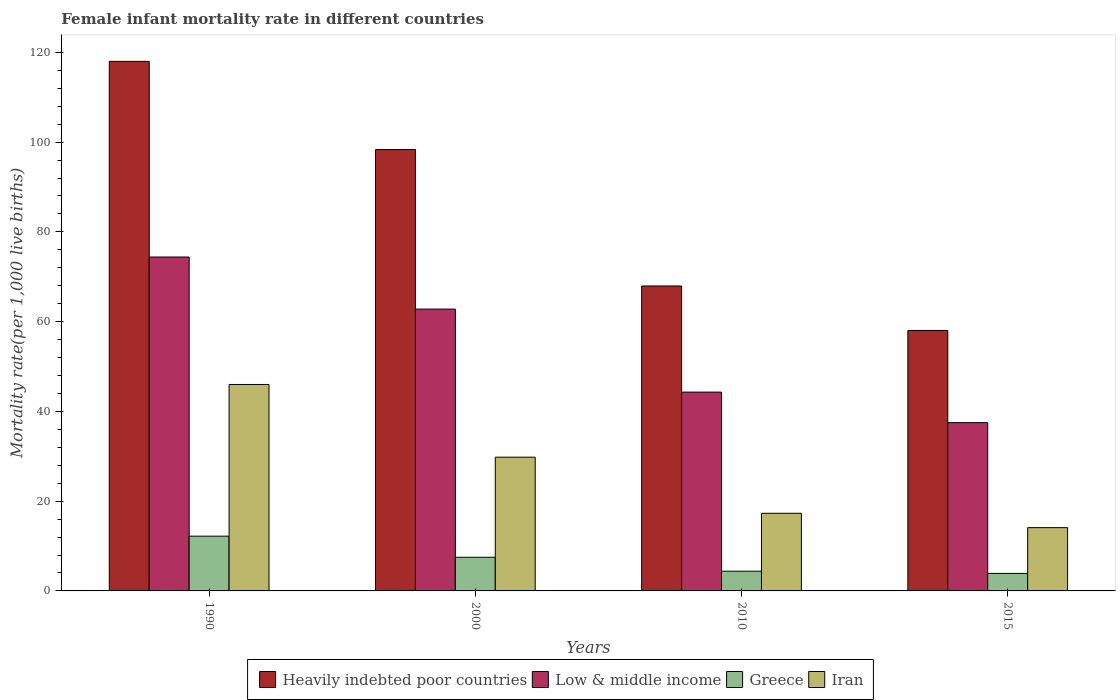How many different coloured bars are there?
Your answer should be compact. 4. How many groups of bars are there?
Offer a terse response. 4. Are the number of bars per tick equal to the number of legend labels?
Your response must be concise. Yes. How many bars are there on the 1st tick from the left?
Keep it short and to the point. 4. How many bars are there on the 3rd tick from the right?
Make the answer very short. 4. What is the label of the 4th group of bars from the left?
Your response must be concise. 2015. In how many cases, is the number of bars for a given year not equal to the number of legend labels?
Your answer should be very brief. 0. What is the female infant mortality rate in Greece in 2010?
Offer a very short reply. 4.4. Across all years, what is the maximum female infant mortality rate in Heavily indebted poor countries?
Your answer should be compact. 118. Across all years, what is the minimum female infant mortality rate in Low & middle income?
Give a very brief answer. 37.5. In which year was the female infant mortality rate in Greece minimum?
Provide a short and direct response. 2015. What is the total female infant mortality rate in Low & middle income in the graph?
Offer a terse response. 219. What is the difference between the female infant mortality rate in Low & middle income in 1990 and that in 2015?
Ensure brevity in your answer.  36.9. What is the difference between the female infant mortality rate in Heavily indebted poor countries in 2000 and the female infant mortality rate in Greece in 1990?
Provide a short and direct response. 86.15. What is the average female infant mortality rate in Low & middle income per year?
Offer a terse response. 54.75. In the year 2000, what is the difference between the female infant mortality rate in Iran and female infant mortality rate in Greece?
Your answer should be very brief. 22.3. In how many years, is the female infant mortality rate in Iran greater than 112?
Make the answer very short. 0. What is the ratio of the female infant mortality rate in Heavily indebted poor countries in 1990 to that in 2010?
Offer a very short reply. 1.74. Is the difference between the female infant mortality rate in Iran in 1990 and 2010 greater than the difference between the female infant mortality rate in Greece in 1990 and 2010?
Your answer should be very brief. Yes. What is the difference between the highest and the second highest female infant mortality rate in Low & middle income?
Give a very brief answer. 11.6. What is the difference between the highest and the lowest female infant mortality rate in Greece?
Ensure brevity in your answer.  8.3. In how many years, is the female infant mortality rate in Greece greater than the average female infant mortality rate in Greece taken over all years?
Your answer should be very brief. 2. What does the 1st bar from the left in 2015 represents?
Offer a very short reply. Heavily indebted poor countries. How many bars are there?
Give a very brief answer. 16. Are the values on the major ticks of Y-axis written in scientific E-notation?
Provide a succinct answer. No. Does the graph contain grids?
Your answer should be compact. No. Where does the legend appear in the graph?
Provide a succinct answer. Bottom center. How are the legend labels stacked?
Your response must be concise. Horizontal. What is the title of the graph?
Ensure brevity in your answer.  Female infant mortality rate in different countries. Does "Djibouti" appear as one of the legend labels in the graph?
Your response must be concise. No. What is the label or title of the Y-axis?
Offer a terse response. Mortality rate(per 1,0 live births). What is the Mortality rate(per 1,000 live births) of Heavily indebted poor countries in 1990?
Your response must be concise. 118. What is the Mortality rate(per 1,000 live births) of Low & middle income in 1990?
Your answer should be compact. 74.4. What is the Mortality rate(per 1,000 live births) of Greece in 1990?
Give a very brief answer. 12.2. What is the Mortality rate(per 1,000 live births) in Heavily indebted poor countries in 2000?
Provide a short and direct response. 98.35. What is the Mortality rate(per 1,000 live births) of Low & middle income in 2000?
Offer a terse response. 62.8. What is the Mortality rate(per 1,000 live births) of Iran in 2000?
Your answer should be very brief. 29.8. What is the Mortality rate(per 1,000 live births) in Heavily indebted poor countries in 2010?
Your answer should be very brief. 67.95. What is the Mortality rate(per 1,000 live births) of Low & middle income in 2010?
Offer a very short reply. 44.3. What is the Mortality rate(per 1,000 live births) of Heavily indebted poor countries in 2015?
Make the answer very short. 58.04. What is the Mortality rate(per 1,000 live births) in Low & middle income in 2015?
Your answer should be compact. 37.5. What is the Mortality rate(per 1,000 live births) of Greece in 2015?
Make the answer very short. 3.9. Across all years, what is the maximum Mortality rate(per 1,000 live births) in Heavily indebted poor countries?
Keep it short and to the point. 118. Across all years, what is the maximum Mortality rate(per 1,000 live births) of Low & middle income?
Your answer should be compact. 74.4. Across all years, what is the maximum Mortality rate(per 1,000 live births) of Iran?
Make the answer very short. 46. Across all years, what is the minimum Mortality rate(per 1,000 live births) in Heavily indebted poor countries?
Make the answer very short. 58.04. Across all years, what is the minimum Mortality rate(per 1,000 live births) in Low & middle income?
Ensure brevity in your answer.  37.5. Across all years, what is the minimum Mortality rate(per 1,000 live births) in Greece?
Keep it short and to the point. 3.9. What is the total Mortality rate(per 1,000 live births) of Heavily indebted poor countries in the graph?
Offer a very short reply. 342.34. What is the total Mortality rate(per 1,000 live births) in Low & middle income in the graph?
Your answer should be very brief. 219. What is the total Mortality rate(per 1,000 live births) in Greece in the graph?
Your response must be concise. 28. What is the total Mortality rate(per 1,000 live births) of Iran in the graph?
Make the answer very short. 107.2. What is the difference between the Mortality rate(per 1,000 live births) in Heavily indebted poor countries in 1990 and that in 2000?
Provide a succinct answer. 19.65. What is the difference between the Mortality rate(per 1,000 live births) of Greece in 1990 and that in 2000?
Your answer should be very brief. 4.7. What is the difference between the Mortality rate(per 1,000 live births) of Iran in 1990 and that in 2000?
Offer a very short reply. 16.2. What is the difference between the Mortality rate(per 1,000 live births) of Heavily indebted poor countries in 1990 and that in 2010?
Give a very brief answer. 50.05. What is the difference between the Mortality rate(per 1,000 live births) in Low & middle income in 1990 and that in 2010?
Your answer should be compact. 30.1. What is the difference between the Mortality rate(per 1,000 live births) of Greece in 1990 and that in 2010?
Your response must be concise. 7.8. What is the difference between the Mortality rate(per 1,000 live births) of Iran in 1990 and that in 2010?
Make the answer very short. 28.7. What is the difference between the Mortality rate(per 1,000 live births) of Heavily indebted poor countries in 1990 and that in 2015?
Your answer should be very brief. 59.96. What is the difference between the Mortality rate(per 1,000 live births) in Low & middle income in 1990 and that in 2015?
Your answer should be compact. 36.9. What is the difference between the Mortality rate(per 1,000 live births) in Greece in 1990 and that in 2015?
Make the answer very short. 8.3. What is the difference between the Mortality rate(per 1,000 live births) in Iran in 1990 and that in 2015?
Provide a succinct answer. 31.9. What is the difference between the Mortality rate(per 1,000 live births) in Heavily indebted poor countries in 2000 and that in 2010?
Your answer should be very brief. 30.4. What is the difference between the Mortality rate(per 1,000 live births) in Heavily indebted poor countries in 2000 and that in 2015?
Keep it short and to the point. 40.31. What is the difference between the Mortality rate(per 1,000 live births) in Low & middle income in 2000 and that in 2015?
Offer a very short reply. 25.3. What is the difference between the Mortality rate(per 1,000 live births) of Greece in 2000 and that in 2015?
Offer a very short reply. 3.6. What is the difference between the Mortality rate(per 1,000 live births) in Iran in 2000 and that in 2015?
Provide a short and direct response. 15.7. What is the difference between the Mortality rate(per 1,000 live births) of Heavily indebted poor countries in 2010 and that in 2015?
Ensure brevity in your answer.  9.91. What is the difference between the Mortality rate(per 1,000 live births) in Low & middle income in 2010 and that in 2015?
Ensure brevity in your answer.  6.8. What is the difference between the Mortality rate(per 1,000 live births) in Greece in 2010 and that in 2015?
Keep it short and to the point. 0.5. What is the difference between the Mortality rate(per 1,000 live births) in Heavily indebted poor countries in 1990 and the Mortality rate(per 1,000 live births) in Low & middle income in 2000?
Ensure brevity in your answer.  55.2. What is the difference between the Mortality rate(per 1,000 live births) of Heavily indebted poor countries in 1990 and the Mortality rate(per 1,000 live births) of Greece in 2000?
Provide a succinct answer. 110.5. What is the difference between the Mortality rate(per 1,000 live births) in Heavily indebted poor countries in 1990 and the Mortality rate(per 1,000 live births) in Iran in 2000?
Your answer should be very brief. 88.2. What is the difference between the Mortality rate(per 1,000 live births) in Low & middle income in 1990 and the Mortality rate(per 1,000 live births) in Greece in 2000?
Ensure brevity in your answer.  66.9. What is the difference between the Mortality rate(per 1,000 live births) of Low & middle income in 1990 and the Mortality rate(per 1,000 live births) of Iran in 2000?
Keep it short and to the point. 44.6. What is the difference between the Mortality rate(per 1,000 live births) in Greece in 1990 and the Mortality rate(per 1,000 live births) in Iran in 2000?
Give a very brief answer. -17.6. What is the difference between the Mortality rate(per 1,000 live births) of Heavily indebted poor countries in 1990 and the Mortality rate(per 1,000 live births) of Low & middle income in 2010?
Make the answer very short. 73.7. What is the difference between the Mortality rate(per 1,000 live births) in Heavily indebted poor countries in 1990 and the Mortality rate(per 1,000 live births) in Greece in 2010?
Make the answer very short. 113.6. What is the difference between the Mortality rate(per 1,000 live births) in Heavily indebted poor countries in 1990 and the Mortality rate(per 1,000 live births) in Iran in 2010?
Your answer should be compact. 100.7. What is the difference between the Mortality rate(per 1,000 live births) in Low & middle income in 1990 and the Mortality rate(per 1,000 live births) in Iran in 2010?
Provide a short and direct response. 57.1. What is the difference between the Mortality rate(per 1,000 live births) of Heavily indebted poor countries in 1990 and the Mortality rate(per 1,000 live births) of Low & middle income in 2015?
Ensure brevity in your answer.  80.5. What is the difference between the Mortality rate(per 1,000 live births) in Heavily indebted poor countries in 1990 and the Mortality rate(per 1,000 live births) in Greece in 2015?
Ensure brevity in your answer.  114.1. What is the difference between the Mortality rate(per 1,000 live births) of Heavily indebted poor countries in 1990 and the Mortality rate(per 1,000 live births) of Iran in 2015?
Your answer should be very brief. 103.9. What is the difference between the Mortality rate(per 1,000 live births) of Low & middle income in 1990 and the Mortality rate(per 1,000 live births) of Greece in 2015?
Your answer should be very brief. 70.5. What is the difference between the Mortality rate(per 1,000 live births) in Low & middle income in 1990 and the Mortality rate(per 1,000 live births) in Iran in 2015?
Your answer should be very brief. 60.3. What is the difference between the Mortality rate(per 1,000 live births) in Heavily indebted poor countries in 2000 and the Mortality rate(per 1,000 live births) in Low & middle income in 2010?
Your answer should be very brief. 54.05. What is the difference between the Mortality rate(per 1,000 live births) in Heavily indebted poor countries in 2000 and the Mortality rate(per 1,000 live births) in Greece in 2010?
Provide a short and direct response. 93.95. What is the difference between the Mortality rate(per 1,000 live births) in Heavily indebted poor countries in 2000 and the Mortality rate(per 1,000 live births) in Iran in 2010?
Offer a very short reply. 81.05. What is the difference between the Mortality rate(per 1,000 live births) in Low & middle income in 2000 and the Mortality rate(per 1,000 live births) in Greece in 2010?
Keep it short and to the point. 58.4. What is the difference between the Mortality rate(per 1,000 live births) of Low & middle income in 2000 and the Mortality rate(per 1,000 live births) of Iran in 2010?
Ensure brevity in your answer.  45.5. What is the difference between the Mortality rate(per 1,000 live births) of Heavily indebted poor countries in 2000 and the Mortality rate(per 1,000 live births) of Low & middle income in 2015?
Ensure brevity in your answer.  60.85. What is the difference between the Mortality rate(per 1,000 live births) in Heavily indebted poor countries in 2000 and the Mortality rate(per 1,000 live births) in Greece in 2015?
Your response must be concise. 94.45. What is the difference between the Mortality rate(per 1,000 live births) in Heavily indebted poor countries in 2000 and the Mortality rate(per 1,000 live births) in Iran in 2015?
Your answer should be very brief. 84.25. What is the difference between the Mortality rate(per 1,000 live births) in Low & middle income in 2000 and the Mortality rate(per 1,000 live births) in Greece in 2015?
Offer a terse response. 58.9. What is the difference between the Mortality rate(per 1,000 live births) of Low & middle income in 2000 and the Mortality rate(per 1,000 live births) of Iran in 2015?
Ensure brevity in your answer.  48.7. What is the difference between the Mortality rate(per 1,000 live births) in Greece in 2000 and the Mortality rate(per 1,000 live births) in Iran in 2015?
Your answer should be very brief. -6.6. What is the difference between the Mortality rate(per 1,000 live births) in Heavily indebted poor countries in 2010 and the Mortality rate(per 1,000 live births) in Low & middle income in 2015?
Offer a terse response. 30.45. What is the difference between the Mortality rate(per 1,000 live births) of Heavily indebted poor countries in 2010 and the Mortality rate(per 1,000 live births) of Greece in 2015?
Provide a short and direct response. 64.05. What is the difference between the Mortality rate(per 1,000 live births) in Heavily indebted poor countries in 2010 and the Mortality rate(per 1,000 live births) in Iran in 2015?
Provide a succinct answer. 53.85. What is the difference between the Mortality rate(per 1,000 live births) of Low & middle income in 2010 and the Mortality rate(per 1,000 live births) of Greece in 2015?
Keep it short and to the point. 40.4. What is the difference between the Mortality rate(per 1,000 live births) of Low & middle income in 2010 and the Mortality rate(per 1,000 live births) of Iran in 2015?
Make the answer very short. 30.2. What is the difference between the Mortality rate(per 1,000 live births) of Greece in 2010 and the Mortality rate(per 1,000 live births) of Iran in 2015?
Offer a very short reply. -9.7. What is the average Mortality rate(per 1,000 live births) in Heavily indebted poor countries per year?
Ensure brevity in your answer.  85.58. What is the average Mortality rate(per 1,000 live births) in Low & middle income per year?
Give a very brief answer. 54.75. What is the average Mortality rate(per 1,000 live births) in Iran per year?
Give a very brief answer. 26.8. In the year 1990, what is the difference between the Mortality rate(per 1,000 live births) in Heavily indebted poor countries and Mortality rate(per 1,000 live births) in Low & middle income?
Offer a very short reply. 43.6. In the year 1990, what is the difference between the Mortality rate(per 1,000 live births) in Heavily indebted poor countries and Mortality rate(per 1,000 live births) in Greece?
Offer a very short reply. 105.8. In the year 1990, what is the difference between the Mortality rate(per 1,000 live births) of Heavily indebted poor countries and Mortality rate(per 1,000 live births) of Iran?
Ensure brevity in your answer.  72. In the year 1990, what is the difference between the Mortality rate(per 1,000 live births) of Low & middle income and Mortality rate(per 1,000 live births) of Greece?
Your response must be concise. 62.2. In the year 1990, what is the difference between the Mortality rate(per 1,000 live births) in Low & middle income and Mortality rate(per 1,000 live births) in Iran?
Provide a short and direct response. 28.4. In the year 1990, what is the difference between the Mortality rate(per 1,000 live births) in Greece and Mortality rate(per 1,000 live births) in Iran?
Ensure brevity in your answer.  -33.8. In the year 2000, what is the difference between the Mortality rate(per 1,000 live births) of Heavily indebted poor countries and Mortality rate(per 1,000 live births) of Low & middle income?
Make the answer very short. 35.55. In the year 2000, what is the difference between the Mortality rate(per 1,000 live births) of Heavily indebted poor countries and Mortality rate(per 1,000 live births) of Greece?
Keep it short and to the point. 90.85. In the year 2000, what is the difference between the Mortality rate(per 1,000 live births) in Heavily indebted poor countries and Mortality rate(per 1,000 live births) in Iran?
Your response must be concise. 68.55. In the year 2000, what is the difference between the Mortality rate(per 1,000 live births) in Low & middle income and Mortality rate(per 1,000 live births) in Greece?
Your answer should be very brief. 55.3. In the year 2000, what is the difference between the Mortality rate(per 1,000 live births) in Greece and Mortality rate(per 1,000 live births) in Iran?
Give a very brief answer. -22.3. In the year 2010, what is the difference between the Mortality rate(per 1,000 live births) in Heavily indebted poor countries and Mortality rate(per 1,000 live births) in Low & middle income?
Give a very brief answer. 23.65. In the year 2010, what is the difference between the Mortality rate(per 1,000 live births) of Heavily indebted poor countries and Mortality rate(per 1,000 live births) of Greece?
Offer a very short reply. 63.55. In the year 2010, what is the difference between the Mortality rate(per 1,000 live births) of Heavily indebted poor countries and Mortality rate(per 1,000 live births) of Iran?
Give a very brief answer. 50.65. In the year 2010, what is the difference between the Mortality rate(per 1,000 live births) in Low & middle income and Mortality rate(per 1,000 live births) in Greece?
Ensure brevity in your answer.  39.9. In the year 2010, what is the difference between the Mortality rate(per 1,000 live births) in Low & middle income and Mortality rate(per 1,000 live births) in Iran?
Your answer should be very brief. 27. In the year 2010, what is the difference between the Mortality rate(per 1,000 live births) in Greece and Mortality rate(per 1,000 live births) in Iran?
Provide a succinct answer. -12.9. In the year 2015, what is the difference between the Mortality rate(per 1,000 live births) of Heavily indebted poor countries and Mortality rate(per 1,000 live births) of Low & middle income?
Make the answer very short. 20.54. In the year 2015, what is the difference between the Mortality rate(per 1,000 live births) of Heavily indebted poor countries and Mortality rate(per 1,000 live births) of Greece?
Ensure brevity in your answer.  54.14. In the year 2015, what is the difference between the Mortality rate(per 1,000 live births) of Heavily indebted poor countries and Mortality rate(per 1,000 live births) of Iran?
Your answer should be very brief. 43.94. In the year 2015, what is the difference between the Mortality rate(per 1,000 live births) of Low & middle income and Mortality rate(per 1,000 live births) of Greece?
Provide a short and direct response. 33.6. In the year 2015, what is the difference between the Mortality rate(per 1,000 live births) of Low & middle income and Mortality rate(per 1,000 live births) of Iran?
Provide a short and direct response. 23.4. What is the ratio of the Mortality rate(per 1,000 live births) of Heavily indebted poor countries in 1990 to that in 2000?
Your response must be concise. 1.2. What is the ratio of the Mortality rate(per 1,000 live births) of Low & middle income in 1990 to that in 2000?
Ensure brevity in your answer.  1.18. What is the ratio of the Mortality rate(per 1,000 live births) of Greece in 1990 to that in 2000?
Ensure brevity in your answer.  1.63. What is the ratio of the Mortality rate(per 1,000 live births) of Iran in 1990 to that in 2000?
Offer a terse response. 1.54. What is the ratio of the Mortality rate(per 1,000 live births) in Heavily indebted poor countries in 1990 to that in 2010?
Provide a short and direct response. 1.74. What is the ratio of the Mortality rate(per 1,000 live births) in Low & middle income in 1990 to that in 2010?
Your response must be concise. 1.68. What is the ratio of the Mortality rate(per 1,000 live births) of Greece in 1990 to that in 2010?
Give a very brief answer. 2.77. What is the ratio of the Mortality rate(per 1,000 live births) of Iran in 1990 to that in 2010?
Provide a short and direct response. 2.66. What is the ratio of the Mortality rate(per 1,000 live births) in Heavily indebted poor countries in 1990 to that in 2015?
Provide a succinct answer. 2.03. What is the ratio of the Mortality rate(per 1,000 live births) in Low & middle income in 1990 to that in 2015?
Your answer should be compact. 1.98. What is the ratio of the Mortality rate(per 1,000 live births) of Greece in 1990 to that in 2015?
Offer a very short reply. 3.13. What is the ratio of the Mortality rate(per 1,000 live births) of Iran in 1990 to that in 2015?
Your answer should be very brief. 3.26. What is the ratio of the Mortality rate(per 1,000 live births) of Heavily indebted poor countries in 2000 to that in 2010?
Provide a short and direct response. 1.45. What is the ratio of the Mortality rate(per 1,000 live births) of Low & middle income in 2000 to that in 2010?
Ensure brevity in your answer.  1.42. What is the ratio of the Mortality rate(per 1,000 live births) of Greece in 2000 to that in 2010?
Keep it short and to the point. 1.7. What is the ratio of the Mortality rate(per 1,000 live births) of Iran in 2000 to that in 2010?
Give a very brief answer. 1.72. What is the ratio of the Mortality rate(per 1,000 live births) in Heavily indebted poor countries in 2000 to that in 2015?
Make the answer very short. 1.69. What is the ratio of the Mortality rate(per 1,000 live births) of Low & middle income in 2000 to that in 2015?
Give a very brief answer. 1.67. What is the ratio of the Mortality rate(per 1,000 live births) in Greece in 2000 to that in 2015?
Offer a terse response. 1.92. What is the ratio of the Mortality rate(per 1,000 live births) of Iran in 2000 to that in 2015?
Ensure brevity in your answer.  2.11. What is the ratio of the Mortality rate(per 1,000 live births) in Heavily indebted poor countries in 2010 to that in 2015?
Keep it short and to the point. 1.17. What is the ratio of the Mortality rate(per 1,000 live births) in Low & middle income in 2010 to that in 2015?
Your answer should be compact. 1.18. What is the ratio of the Mortality rate(per 1,000 live births) in Greece in 2010 to that in 2015?
Offer a terse response. 1.13. What is the ratio of the Mortality rate(per 1,000 live births) of Iran in 2010 to that in 2015?
Offer a very short reply. 1.23. What is the difference between the highest and the second highest Mortality rate(per 1,000 live births) in Heavily indebted poor countries?
Offer a terse response. 19.65. What is the difference between the highest and the second highest Mortality rate(per 1,000 live births) of Iran?
Your response must be concise. 16.2. What is the difference between the highest and the lowest Mortality rate(per 1,000 live births) in Heavily indebted poor countries?
Ensure brevity in your answer.  59.96. What is the difference between the highest and the lowest Mortality rate(per 1,000 live births) in Low & middle income?
Make the answer very short. 36.9. What is the difference between the highest and the lowest Mortality rate(per 1,000 live births) of Iran?
Offer a very short reply. 31.9. 